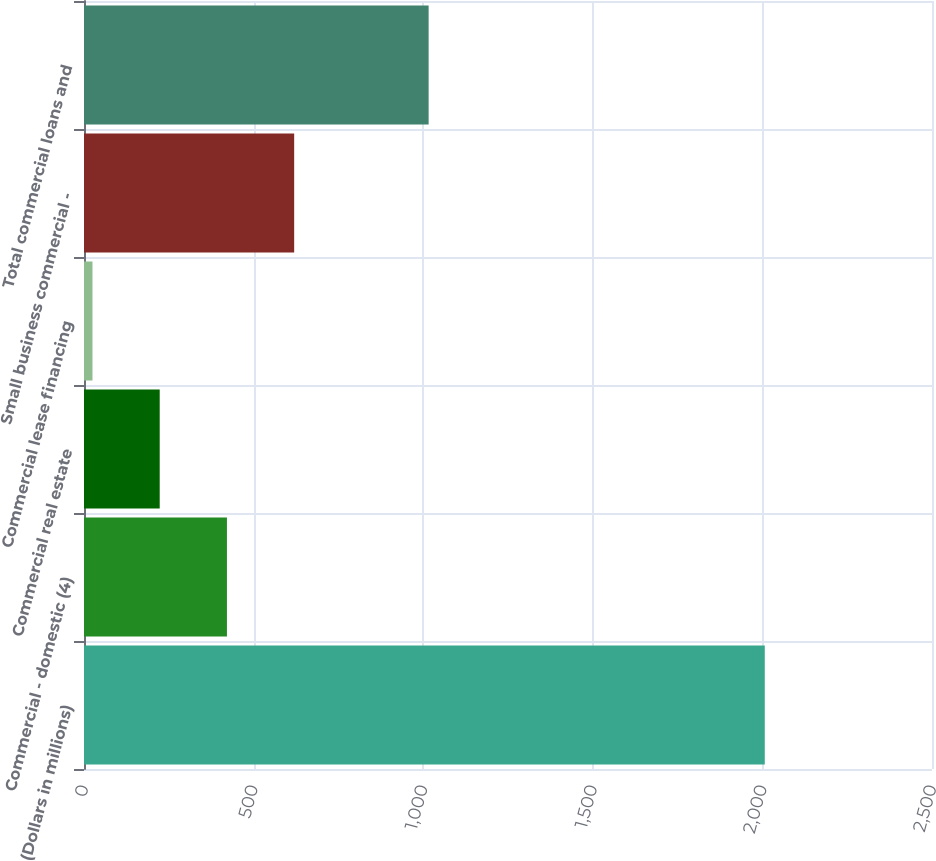<chart> <loc_0><loc_0><loc_500><loc_500><bar_chart><fcel>(Dollars in millions)<fcel>Commercial - domestic (4)<fcel>Commercial real estate<fcel>Commercial lease financing<fcel>Small business commercial -<fcel>Total commercial loans and<nl><fcel>2007<fcel>421.4<fcel>223.2<fcel>25<fcel>619.6<fcel>1016<nl></chart> 